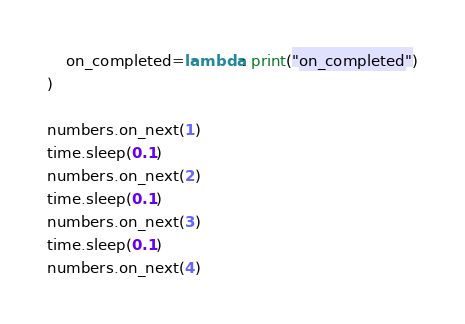<code> <loc_0><loc_0><loc_500><loc_500><_Python_>    on_completed=lambda: print("on_completed")
)

numbers.on_next(1)
time.sleep(0.1)
numbers.on_next(2)
time.sleep(0.1)
numbers.on_next(3)
time.sleep(0.1)
numbers.on_next(4)
</code> 